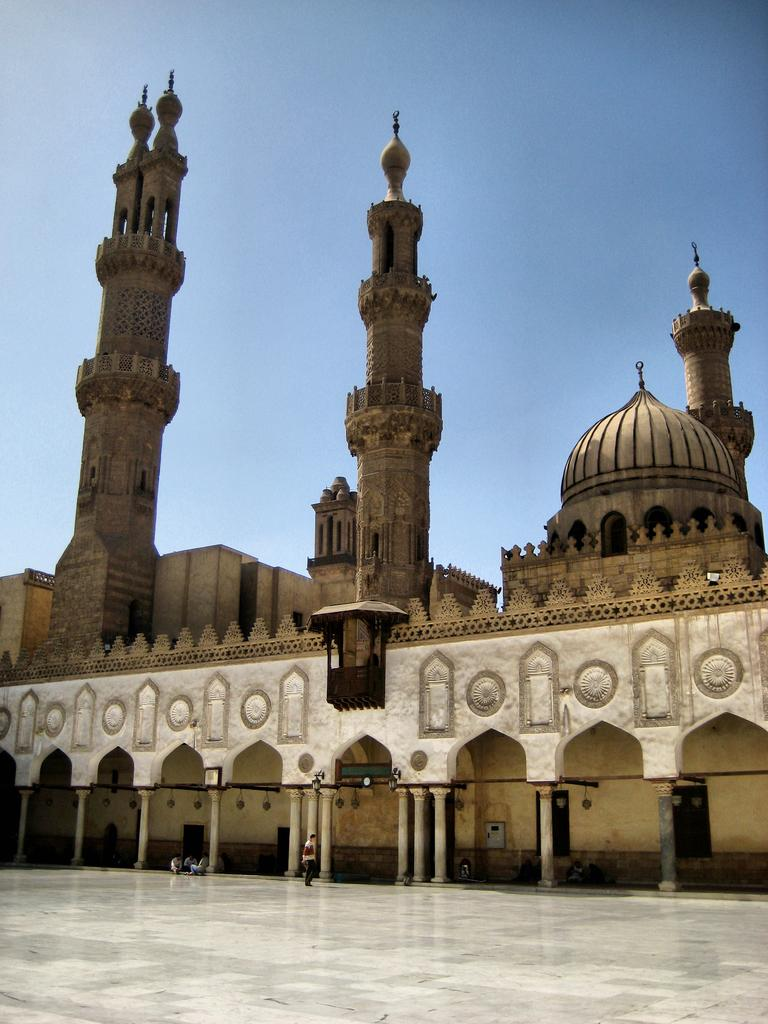What type of structure is present in the image? There is a building in the image. What colors are used for the building? The building is in brown and cream color. Are there any people near the building? Yes, there are people in front of the building. What can be seen in the background of the image? The sky is blue in the background of the image. Can you see any quivers hanging on the building in the image? There are no quivers present in the image. What type of fruit is being sold by the people in front of the building? There is no fruit visible in the image, nor are the people selling anything. 